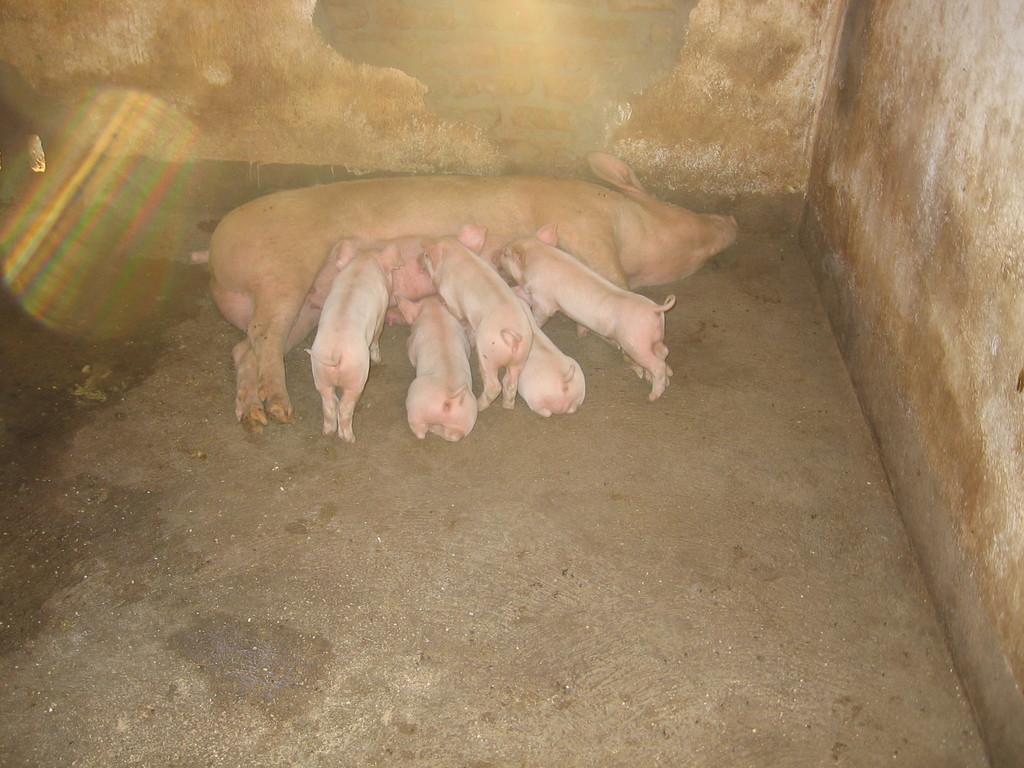Describe this image in one or two sentences. At the bottom, we see the pavement. On the right side, we see a wall. In the middle, we see a pig and five piglets. In the background, we see a wall. 